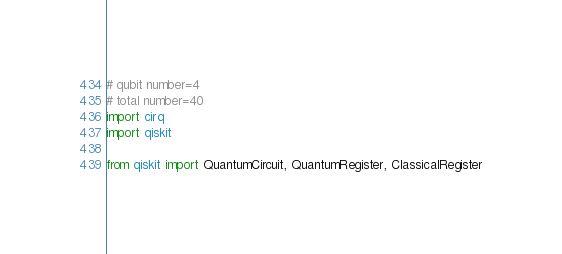<code> <loc_0><loc_0><loc_500><loc_500><_Python_># qubit number=4
# total number=40
import cirq
import qiskit

from qiskit import QuantumCircuit, QuantumRegister, ClassicalRegister</code> 